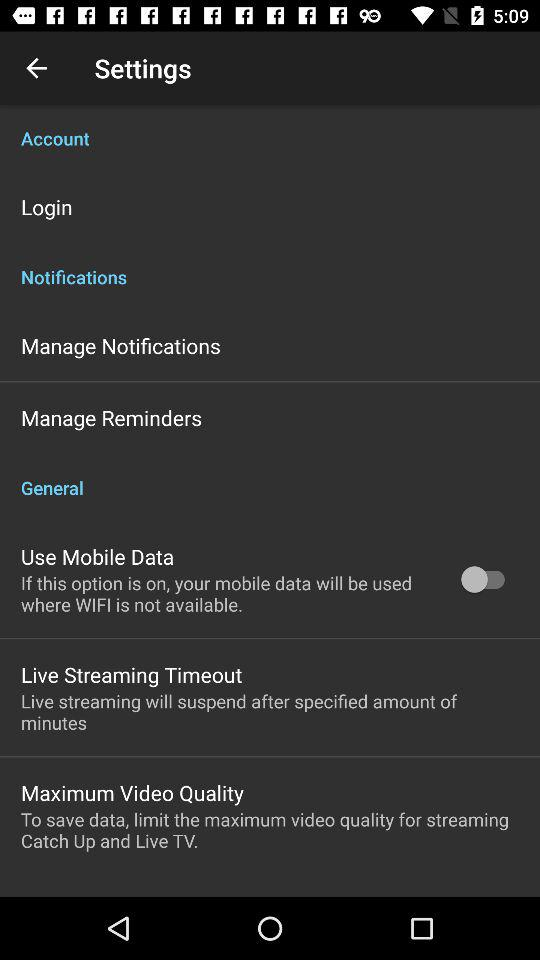How many items are in the general section?
Answer the question using a single word or phrase. 3 